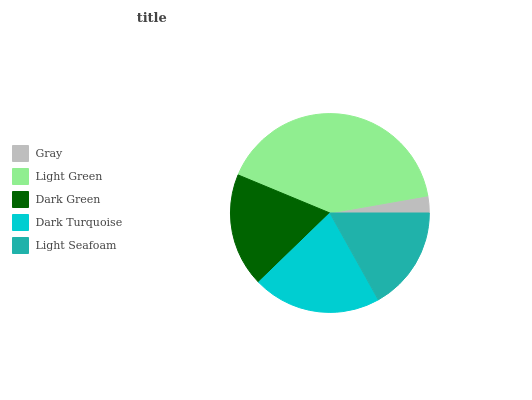Is Gray the minimum?
Answer yes or no. Yes. Is Light Green the maximum?
Answer yes or no. Yes. Is Dark Green the minimum?
Answer yes or no. No. Is Dark Green the maximum?
Answer yes or no. No. Is Light Green greater than Dark Green?
Answer yes or no. Yes. Is Dark Green less than Light Green?
Answer yes or no. Yes. Is Dark Green greater than Light Green?
Answer yes or no. No. Is Light Green less than Dark Green?
Answer yes or no. No. Is Dark Green the high median?
Answer yes or no. Yes. Is Dark Green the low median?
Answer yes or no. Yes. Is Dark Turquoise the high median?
Answer yes or no. No. Is Light Green the low median?
Answer yes or no. No. 